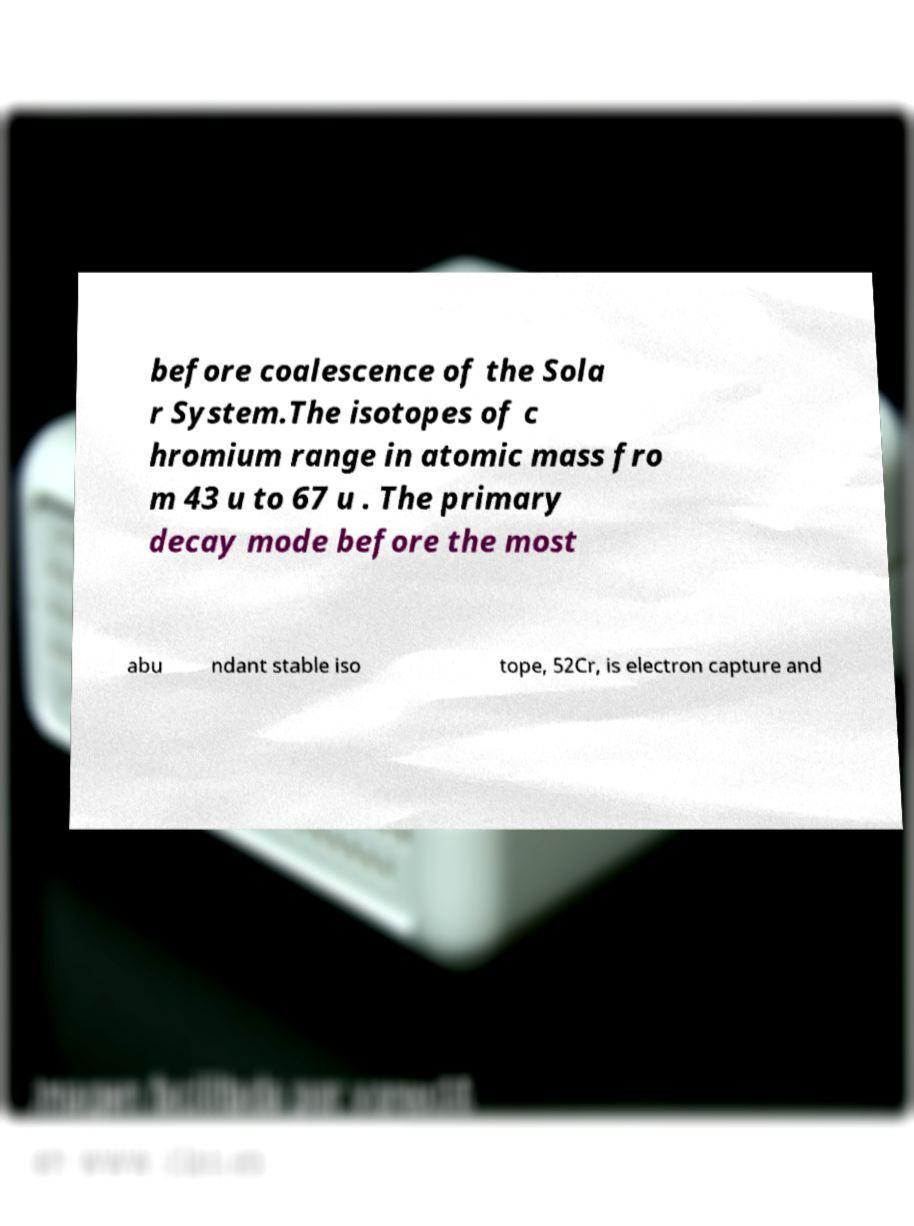Please identify and transcribe the text found in this image. before coalescence of the Sola r System.The isotopes of c hromium range in atomic mass fro m 43 u to 67 u . The primary decay mode before the most abu ndant stable iso tope, 52Cr, is electron capture and 